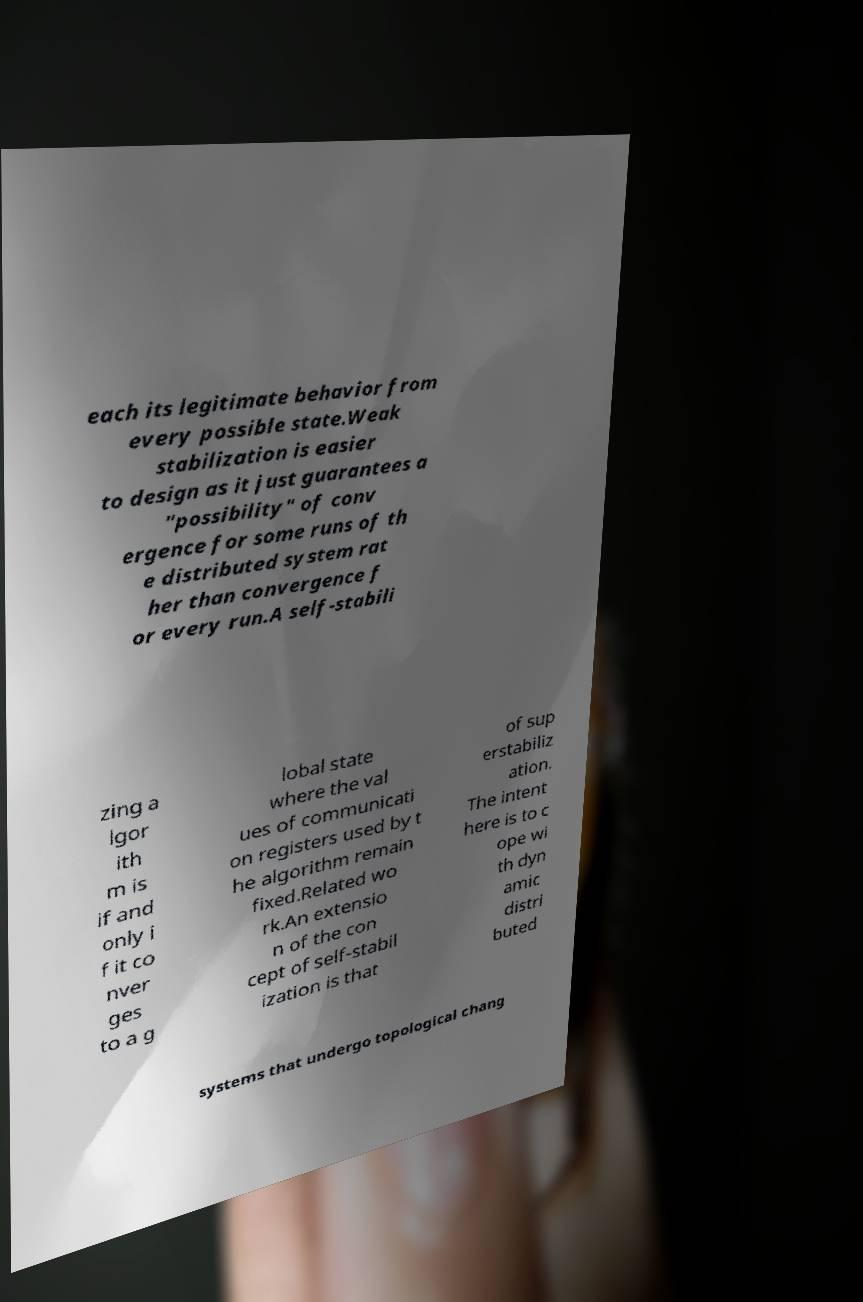For documentation purposes, I need the text within this image transcribed. Could you provide that? each its legitimate behavior from every possible state.Weak stabilization is easier to design as it just guarantees a "possibility" of conv ergence for some runs of th e distributed system rat her than convergence f or every run.A self-stabili zing a lgor ith m is if and only i f it co nver ges to a g lobal state where the val ues of communicati on registers used by t he algorithm remain fixed.Related wo rk.An extensio n of the con cept of self-stabil ization is that of sup erstabiliz ation. The intent here is to c ope wi th dyn amic distri buted systems that undergo topological chang 